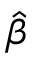<formula> <loc_0><loc_0><loc_500><loc_500>\hat { \beta }</formula> 